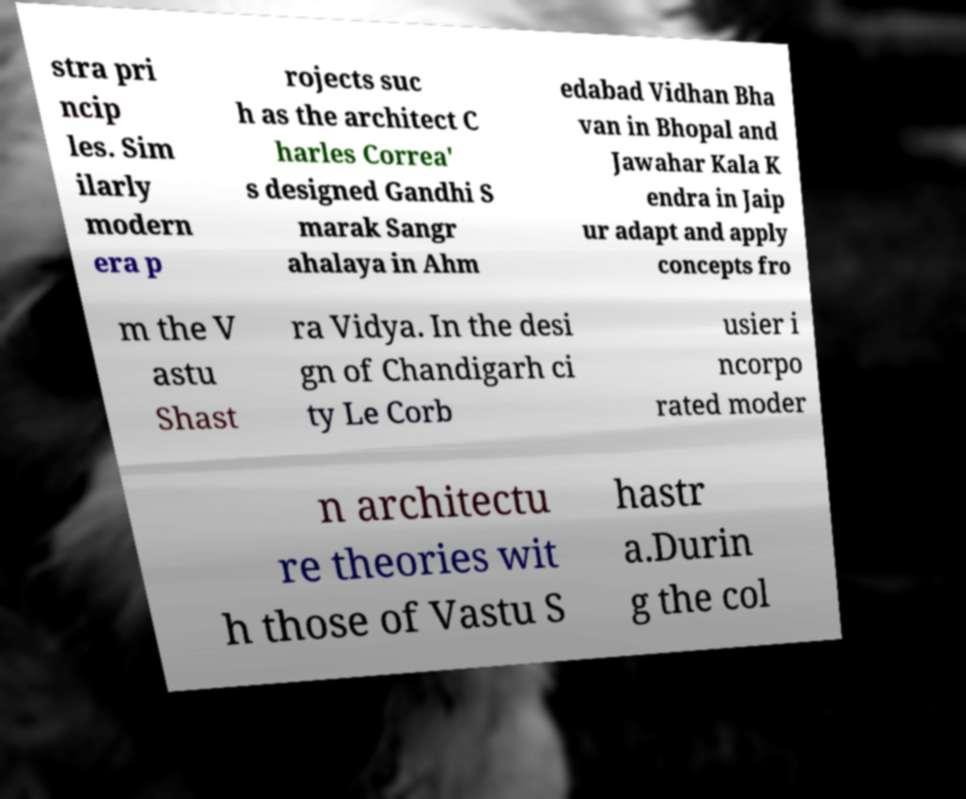Please read and relay the text visible in this image. What does it say? stra pri ncip les. Sim ilarly modern era p rojects suc h as the architect C harles Correa' s designed Gandhi S marak Sangr ahalaya in Ahm edabad Vidhan Bha van in Bhopal and Jawahar Kala K endra in Jaip ur adapt and apply concepts fro m the V astu Shast ra Vidya. In the desi gn of Chandigarh ci ty Le Corb usier i ncorpo rated moder n architectu re theories wit h those of Vastu S hastr a.Durin g the col 